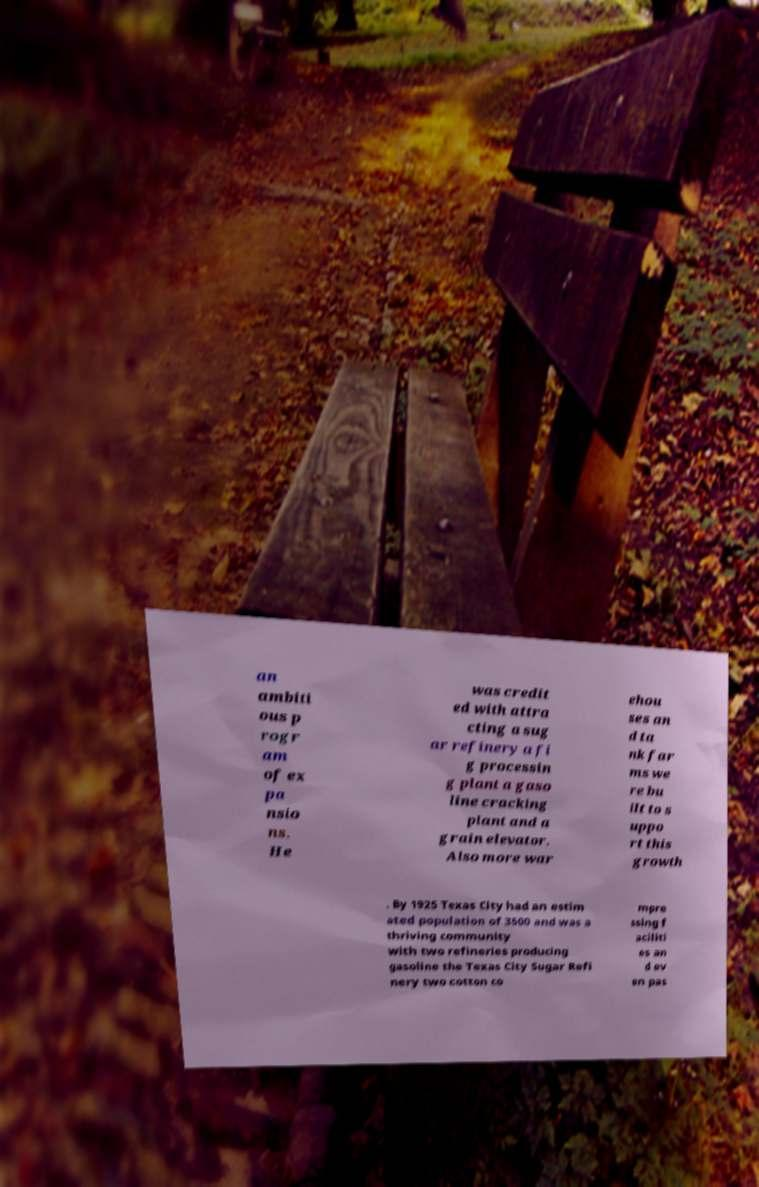What messages or text are displayed in this image? I need them in a readable, typed format. an ambiti ous p rogr am of ex pa nsio ns. He was credit ed with attra cting a sug ar refinery a fi g processin g plant a gaso line cracking plant and a grain elevator. Also more war ehou ses an d ta nk far ms we re bu ilt to s uppo rt this growth . By 1925 Texas City had an estim ated population of 3500 and was a thriving community with two refineries producing gasoline the Texas City Sugar Refi nery two cotton co mpre ssing f aciliti es an d ev en pas 